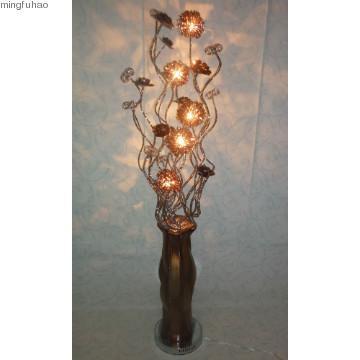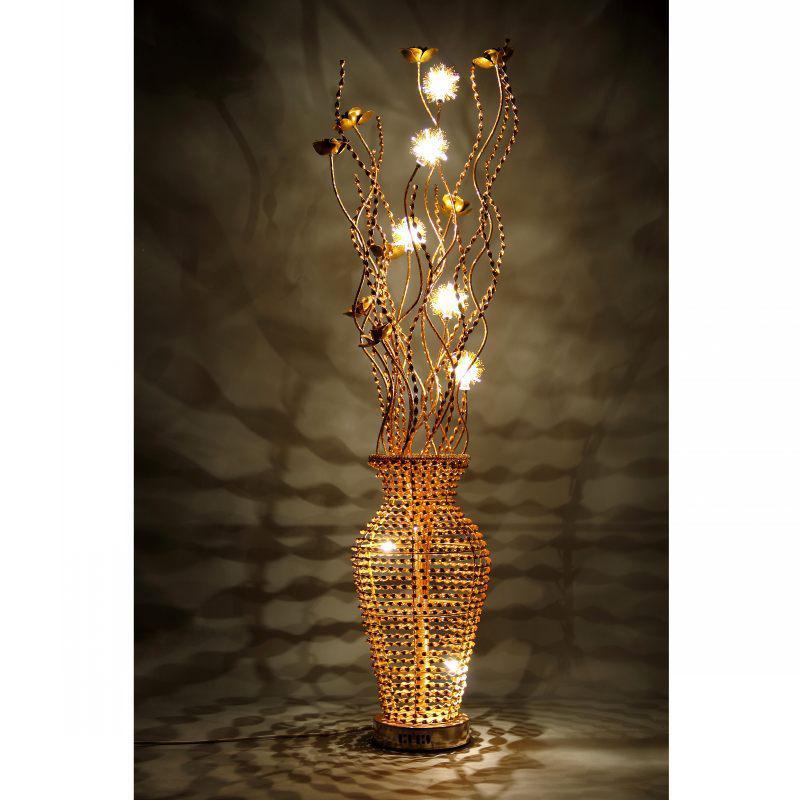The first image is the image on the left, the second image is the image on the right. Assess this claim about the two images: "There is a silver lamp with white lights in the right image.". Correct or not? Answer yes or no. No. 